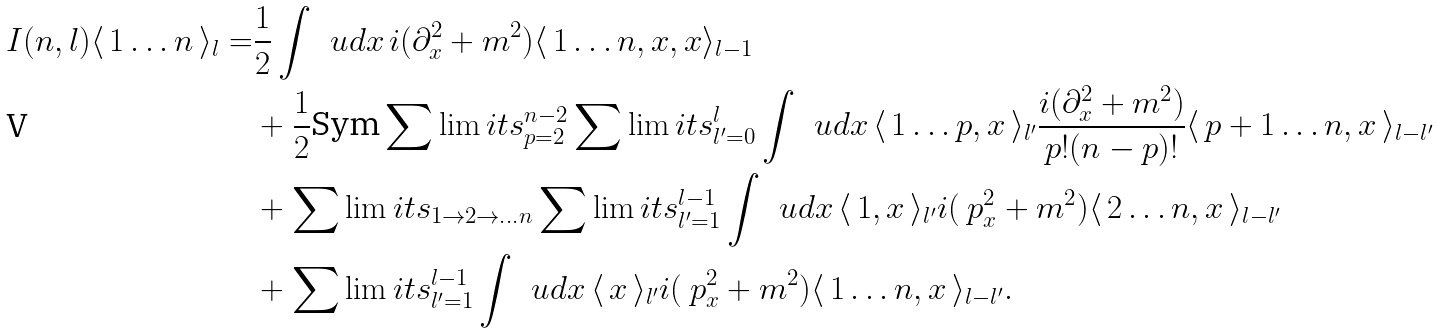Convert formula to latex. <formula><loc_0><loc_0><loc_500><loc_500>I ( n , l ) \langle \, 1 \dots n \, \rangle _ { l } = & \frac { 1 } { 2 } \int \, \ u d x \, i ( \partial ^ { 2 } _ { x } + m ^ { 2 } ) \langle \, 1 \dots n , x , x \rangle _ { l - 1 } \\ & + \frac { 1 } { 2 } \text {Sym} \sum \lim i t s _ { p = 2 } ^ { n - 2 } \sum \lim i t s _ { l ^ { \prime } = 0 } ^ { l } \int \, \ u d x \, \langle \, 1 \dots p , x \, \rangle _ { l ^ { \prime } } \frac { i ( \partial ^ { 2 } _ { x } + m ^ { 2 } ) } { p ! ( n - p ) ! } \langle \, p + 1 \dots n , x \, \rangle _ { l - l ^ { \prime } } \\ & + \sum \lim i t s _ { 1 \rightarrow 2 \rightarrow \dots n } \sum \lim i t s _ { l ^ { \prime } = 1 } ^ { l - 1 } \int \, \ u d x \, \langle \, 1 , x \, \rangle _ { l ^ { \prime } } i ( \ p ^ { 2 } _ { x } + m ^ { 2 } ) \langle \, 2 \dots n , x \, \rangle _ { l - l ^ { \prime } } \\ & + \sum \lim i t s _ { l ^ { \prime } = 1 } ^ { l - 1 } \int \, \ u d x \, \langle \, x \, \rangle _ { l ^ { \prime } } i ( \ p ^ { 2 } _ { x } + m ^ { 2 } ) \langle \, 1 \dots n , x \, \rangle _ { l - l ^ { \prime } } .</formula> 